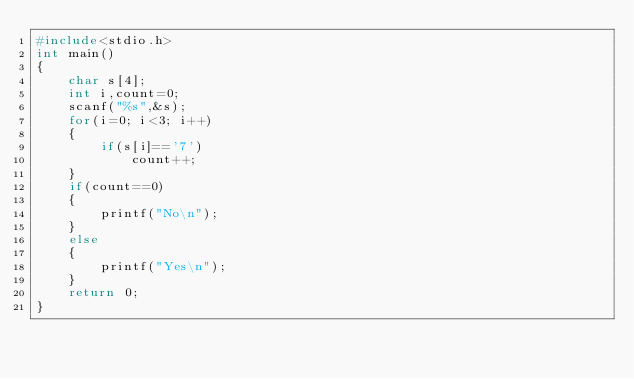<code> <loc_0><loc_0><loc_500><loc_500><_C_>#include<stdio.h>
int main()
{
    char s[4];
    int i,count=0;
    scanf("%s",&s);
    for(i=0; i<3; i++)
    {
        if(s[i]=='7')
            count++;
    }
    if(count==0)
    {
        printf("No\n");
    }
    else
    {
        printf("Yes\n");
    }
    return 0;
}
</code> 